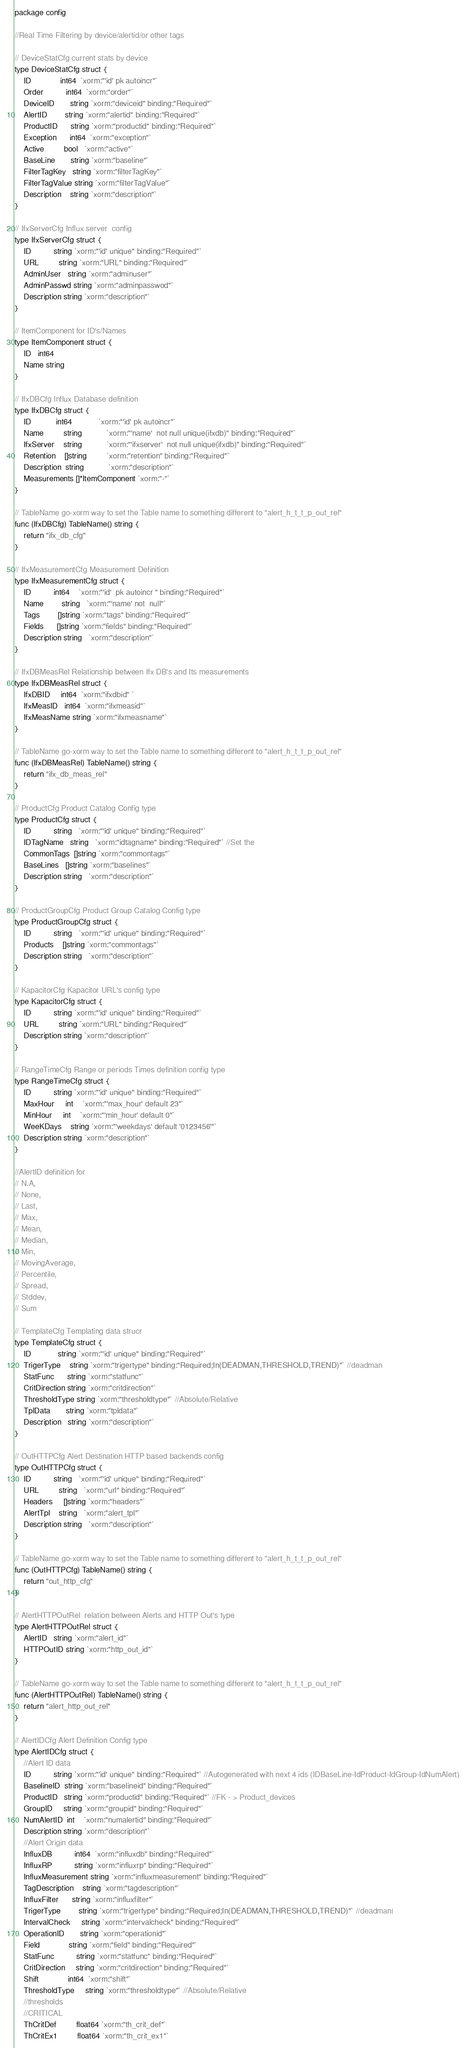Convert code to text. <code><loc_0><loc_0><loc_500><loc_500><_Go_>package config

//Real Time Filtering by device/alertid/or other tags

// DeviceStatCfg current stats by device
type DeviceStatCfg struct {
	ID             int64  `xorm:"'id' pk autoincr"`
	Order          int64  `xorm:"order"`
	DeviceID       string `xorm:"deviceid" binding:"Required"`
	AlertID        string `xorm:"alertid" binding:"Required"`
	ProductID      string `xorm:"productid" binding:"Required"`
	Exception      int64  `xorm:"exception"`
	Active         bool   `xorm:"active"`
	BaseLine       string `xorm:"baseline"`
	FilterTagKey   string `xorm:"filterTagKey"`
	FilterTagValue string `xorm:"filterTagValue"`
	Description    string `xorm:"description"`
}

// IfxServerCfg Influx server  config
type IfxServerCfg struct {
	ID          string `xorm:"'id' unique" binding:"Required"`
	URL         string `xorm:"URL" binding:"Required"`
	AdminUser   string `xorm:"adminuser"`
	AdminPasswd string `xorm:"adminpasswod"`
	Description string `xorm:"description"`
}

// ItemComponent for ID's/Names
type ItemComponent struct {
	ID   int64
	Name string
}

// IfxDBCfg Influx Database definition
type IfxDBCfg struct {
	ID           int64            `xorm:"'id' pk autoincr"`
	Name         string           `xorm:"'name'  not null unique(ifxdb)" binding:"Required"`
	IfxServer    string           `xorm:"'ifxserver'  not null unique(ifxdb)" binding:"Required"`
	Retention    []string         `xorm:"retention" binding:"Required"`
	Description  string           `xorm:"description"`
	Measurements []*ItemComponent `xorm:"-"`
}

// TableName go-xorm way to set the Table name to something different to "alert_h_t_t_p_out_rel"
func (IfxDBCfg) TableName() string {
	return "ifx_db_cfg"
}

// IfxMeasurementCfg Measurement Definition
type IfxMeasurementCfg struct {
	ID          int64    `xorm:"'id'  pk autoincr " binding:"Required"`
	Name        string   `xorm:"'name' not  null"`
	Tags        []string `xorm:"tags" binding:"Required"`
	Fields      []string `xorm:"fields" binding:"Required"`
	Description string   `xorm:"description"`
}

// IfxDBMeasRel Relationship between Ifx DB's and Its measurements
type IfxDBMeasRel struct {
	IfxDBID     int64  `xorm:"ifxdbid" `
	IfxMeasID   int64  `xorm:"ifxmeasid"`
	IfxMeasName string `xorm:"ifxmeasname"`
}

// TableName go-xorm way to set the Table name to something different to "alert_h_t_t_p_out_rel"
func (IfxDBMeasRel) TableName() string {
	return "ifx_db_meas_rel"
}

// ProductCfg Product Catalog Config type
type ProductCfg struct {
	ID          string   `xorm:"'id' unique" binding:"Required"`
	IDTagName   string   `xorm:"idtagname" binding:"Required"` //Set the
	CommonTags  []string `xorm:"commontags"`
	BaseLines   []string `xorm:"baselines"`
	Description string   `xorm:"description"`
}

// ProductGroupCfg Product Group Catalog Config type
type ProductGroupCfg struct {
	ID          string   `xorm:"'id' unique" binding:"Required"`
	Products    []string `xorm:"commontags"`
	Description string   `xorm:"description"`
}

// KapacitorCfg Kapacitor URL's config type
type KapacitorCfg struct {
	ID          string `xorm:"'id' unique" binding:"Required"`
	URL         string `xorm:"URL" binding:"Required"`
	Description string `xorm:"description"`
}

// RangeTimeCfg Range or periods Times definition config type
type RangeTimeCfg struct {
	ID          string `xorm:"'id' unique" binding:"Required"`
	MaxHour     int    `xorm:"'max_hour' default 23"`
	MinHour     int    `xorm:"'min_hour' default 0"`
	WeeKDays    string `xorm:"'weekdays' default '0123456'"`
	Description string `xorm:"description"`
}

//AlertID definition for
// N.A,
// None,
// Last,
// Max,
// Mean,
// Median,
// Min,
// MovingAverage,
// Percentile,
// Spread,
// Stddev,
// Sum

// TemplateCfg Templating data strucr
type TemplateCfg struct {
	ID            string `xorm:"'id' unique" binding:"Required"`
	TrigerType    string `xorm:"trigertype" binding:"Required;In(DEADMAN,THRESHOLD,TREND)"` //deadman
	StatFunc      string `xorm:"statfunc"`
	CritDirection string `xorm:"critdirection"`
	ThresholdType string `xorm:"thresholdtype"` //Absolute/Relative
	TplData       string `xorm:"tpldata"`
	Description   string `xorm:"description"`
}

// OutHTTPCfg Alert Destination HTTP based backends config
type OutHTTPCfg struct {
	ID          string   `xorm:"'id' unique" binding:"Required"`
	URL         string   `xorm:"url" binding:"Required"`
	Headers     []string `xorm:"headers"`
	AlertTpl    string   `xorm:"alert_tpl"`
	Description string   `xorm:"description"`
}

// TableName go-xorm way to set the Table name to something different to "alert_h_t_t_p_out_rel"
func (OutHTTPCfg) TableName() string {
	return "out_http_cfg"
}

// AlertHTTPOutRel  relation between Alerts and HTTP Out's type
type AlertHTTPOutRel struct {
	AlertID   string `xorm:"alert_id"`
	HTTPOutID string `xorm:"http_out_id"`
}

// TableName go-xorm way to set the Table name to something different to "alert_h_t_t_p_out_rel"
func (AlertHTTPOutRel) TableName() string {
	return "alert_http_out_rel"
}

// AlertIDCfg Alert Definition Config type
type AlertIDCfg struct {
	//Alert ID data
	ID          string `xorm:"'id' unique" binding:"Required"` //Autogenerated with next 4 ids (IDBaseLine-IdProduct-IdGroup-IdNumAlert)
	BaselineID  string `xorm:"baselineid" binding:"Required"`
	ProductID   string `xorm:"productid" binding:"Required"` //FK - > Product_devices
	GroupID     string `xorm:"groupid" binding:"Required"`
	NumAlertID  int    `xorm:"numalertid" binding:"Required"`
	Description string `xorm:"description"`
	//Alert Origin data
	InfluxDB          int64  `xorm:"influxdb" binding:"Required"`
	InfluxRP          string `xorm:"influxrp" binding:"Required"`
	InfluxMeasurement string `xorm:"influxmeasurement" binding:"Required"`
	TagDescription    string `xorm:"tagdescription"`
	InfluxFilter      string `xorm:"influxfilter"`
	TrigerType        string `xorm:"trigertype" binding:"Required;In(DEADMAN,THRESHOLD,TREND)"` //deadman|
	IntervalCheck     string `xorm:"intervalcheck" binding:"Required"`
	OperationID       string `xorm:"operationid"`
	Field             string `xorm:"field" binding:"Required"`
	StatFunc          string `xorm:"statfunc" binding:"Required"`
	CritDirection     string `xorm:"critdirection" binding:"Required"`
	Shift             int64  `xorm:"shift"`
	ThresholdType     string `xorm:"thresholdtype"` //Absolute/Relative
	//thresholds
	//CRITICAL
	ThCritDef         float64 `xorm:"th_crit_def"`
	ThCritEx1         float64 `xorm:"th_crit_ex1"`</code> 